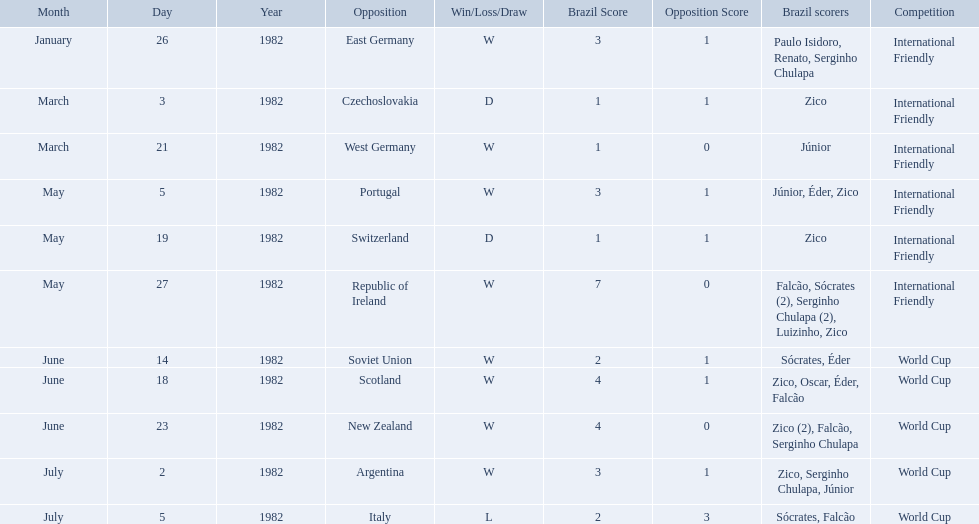What are the dates January 26, 1982, March 3, 1982, March 21, 1982, May 5, 1982, May 19, 1982, May 27, 1982, June 14, 1982, June 18, 1982, June 23, 1982, July 2, 1982, July 5, 1982. Which date is at the top? January 26, 1982. What are all the dates of games in 1982 in brazilian football? January 26, 1982, March 3, 1982, March 21, 1982, May 5, 1982, May 19, 1982, May 27, 1982, June 14, 1982, June 18, 1982, June 23, 1982, July 2, 1982, July 5, 1982. Which of these dates is at the top of the chart? January 26, 1982. How many goals did brazil score against the soviet union? 2-1. How many goals did brazil score against portugal? 3-1. Did brazil score more goals against portugal or the soviet union? Portugal. 